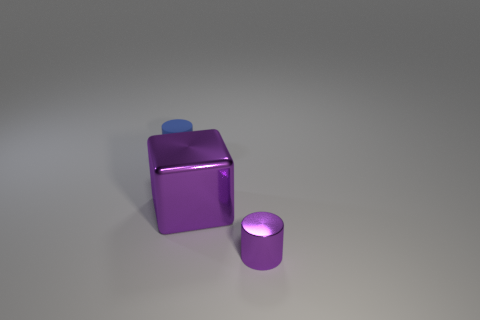Add 2 small brown shiny cubes. How many objects exist? 5 Subtract all blocks. How many objects are left? 2 Subtract all tiny brown objects. Subtract all metal blocks. How many objects are left? 2 Add 2 tiny blue things. How many tiny blue things are left? 3 Add 2 big blocks. How many big blocks exist? 3 Subtract 1 purple cylinders. How many objects are left? 2 